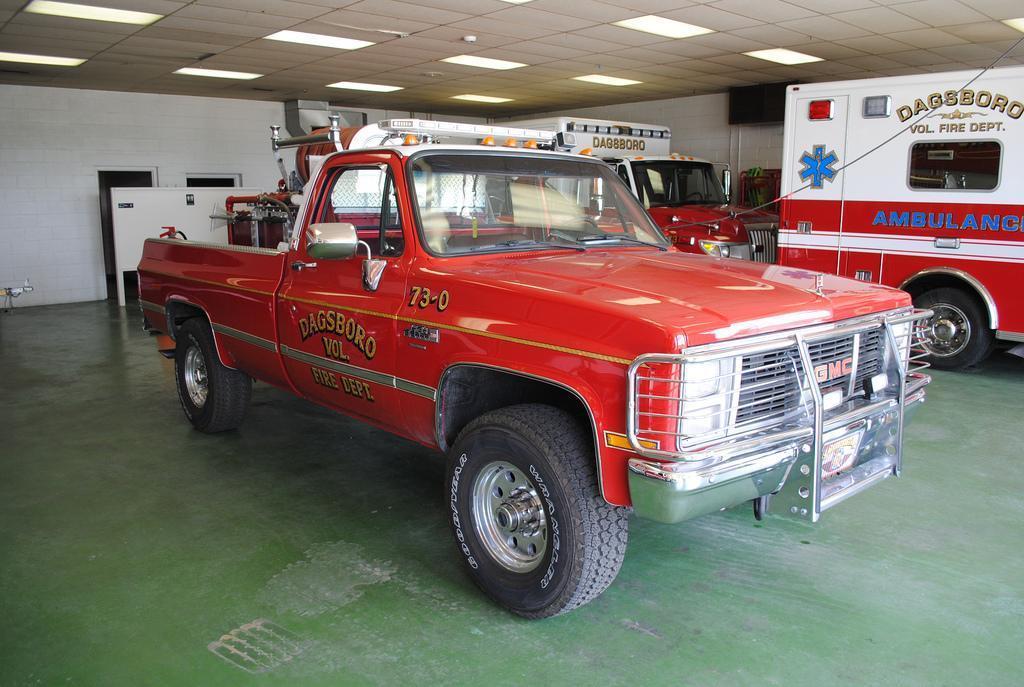How many vehicles are shown?
Give a very brief answer. 3. How many ambulances are there?
Give a very brief answer. 2. How many doors are on the low wall?
Give a very brief answer. 2. 